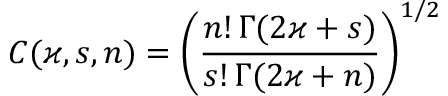Convert formula to latex. <formula><loc_0><loc_0><loc_500><loc_500>C ( \varkappa , s , n ) = \left ( \frac { n ! \, \Gamma ( 2 \varkappa + s ) } { s ! \, \Gamma ( 2 \varkappa + n ) } \right ) ^ { 1 / 2 }</formula> 